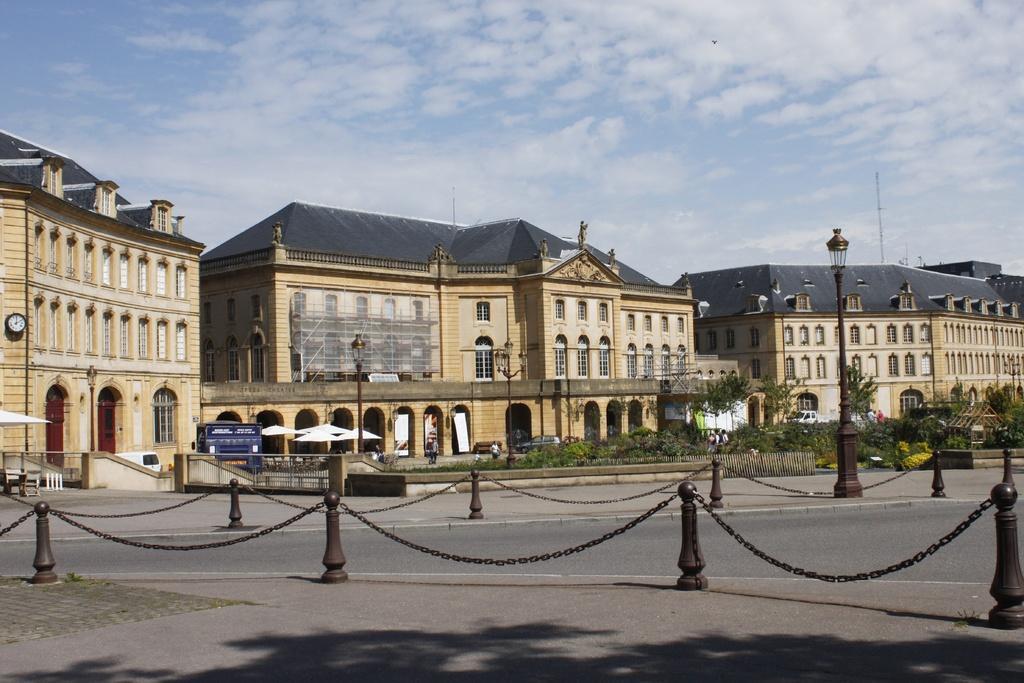Describe this image in one or two sentences. In this image I can see chain railings, light poles, buildings, trees, umbrellas, boards, clock, people, plants, fence, cloudy sky and objects.   